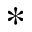Convert formula to latex. <formula><loc_0><loc_0><loc_500><loc_500>\ast</formula> 